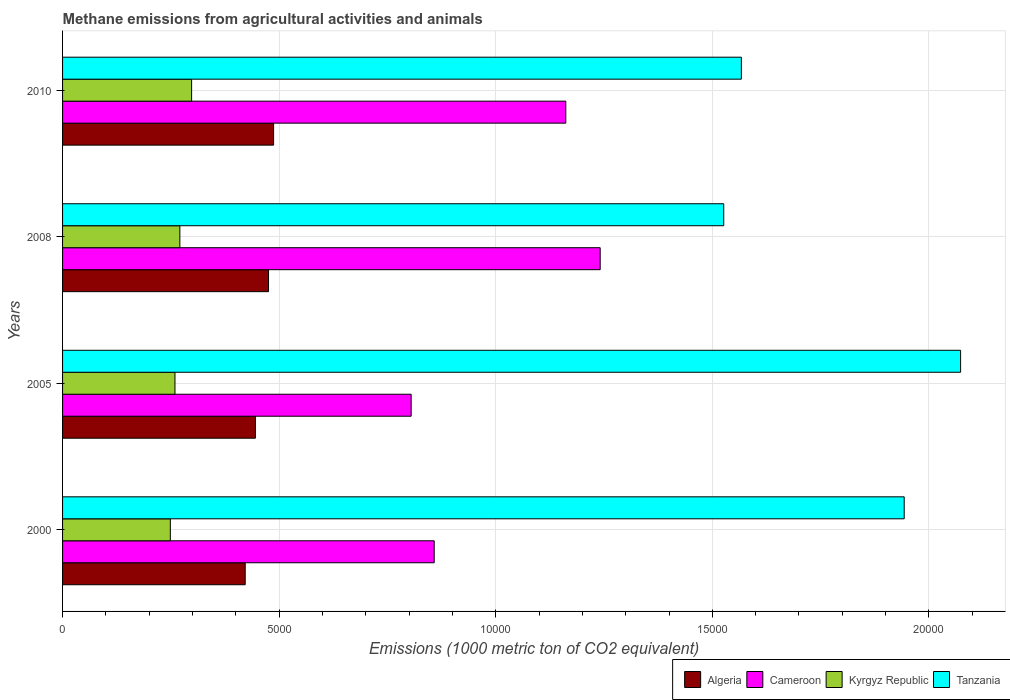Are the number of bars per tick equal to the number of legend labels?
Offer a terse response. Yes. Are the number of bars on each tick of the Y-axis equal?
Ensure brevity in your answer.  Yes. How many bars are there on the 2nd tick from the top?
Keep it short and to the point. 4. How many bars are there on the 2nd tick from the bottom?
Make the answer very short. 4. What is the label of the 2nd group of bars from the top?
Provide a succinct answer. 2008. In how many cases, is the number of bars for a given year not equal to the number of legend labels?
Keep it short and to the point. 0. What is the amount of methane emitted in Tanzania in 2000?
Make the answer very short. 1.94e+04. Across all years, what is the maximum amount of methane emitted in Algeria?
Your response must be concise. 4872.2. Across all years, what is the minimum amount of methane emitted in Tanzania?
Offer a very short reply. 1.53e+04. In which year was the amount of methane emitted in Kyrgyz Republic maximum?
Make the answer very short. 2010. In which year was the amount of methane emitted in Algeria minimum?
Make the answer very short. 2000. What is the total amount of methane emitted in Algeria in the graph?
Ensure brevity in your answer.  1.83e+04. What is the difference between the amount of methane emitted in Tanzania in 2000 and that in 2008?
Offer a terse response. 4166.4. What is the difference between the amount of methane emitted in Kyrgyz Republic in 2010 and the amount of methane emitted in Cameroon in 2008?
Your answer should be very brief. -9432.4. What is the average amount of methane emitted in Cameroon per year?
Your answer should be compact. 1.02e+04. In the year 2008, what is the difference between the amount of methane emitted in Cameroon and amount of methane emitted in Algeria?
Offer a very short reply. 7656.6. In how many years, is the amount of methane emitted in Algeria greater than 15000 1000 metric ton?
Offer a terse response. 0. What is the ratio of the amount of methane emitted in Tanzania in 2000 to that in 2010?
Provide a succinct answer. 1.24. What is the difference between the highest and the second highest amount of methane emitted in Cameroon?
Your answer should be compact. 793.8. What is the difference between the highest and the lowest amount of methane emitted in Tanzania?
Offer a very short reply. 5468. Is the sum of the amount of methane emitted in Tanzania in 2008 and 2010 greater than the maximum amount of methane emitted in Kyrgyz Republic across all years?
Make the answer very short. Yes. Is it the case that in every year, the sum of the amount of methane emitted in Algeria and amount of methane emitted in Tanzania is greater than the sum of amount of methane emitted in Cameroon and amount of methane emitted in Kyrgyz Republic?
Your response must be concise. Yes. What does the 4th bar from the top in 2010 represents?
Provide a succinct answer. Algeria. What does the 4th bar from the bottom in 2010 represents?
Provide a succinct answer. Tanzania. Is it the case that in every year, the sum of the amount of methane emitted in Algeria and amount of methane emitted in Cameroon is greater than the amount of methane emitted in Tanzania?
Make the answer very short. No. How many years are there in the graph?
Offer a very short reply. 4. Does the graph contain any zero values?
Offer a terse response. No. Does the graph contain grids?
Your response must be concise. Yes. How are the legend labels stacked?
Offer a very short reply. Horizontal. What is the title of the graph?
Offer a terse response. Methane emissions from agricultural activities and animals. Does "New Zealand" appear as one of the legend labels in the graph?
Provide a succinct answer. No. What is the label or title of the X-axis?
Your response must be concise. Emissions (1000 metric ton of CO2 equivalent). What is the label or title of the Y-axis?
Your answer should be compact. Years. What is the Emissions (1000 metric ton of CO2 equivalent) of Algeria in 2000?
Your answer should be compact. 4216.3. What is the Emissions (1000 metric ton of CO2 equivalent) of Cameroon in 2000?
Offer a very short reply. 8579.6. What is the Emissions (1000 metric ton of CO2 equivalent) of Kyrgyz Republic in 2000?
Provide a short and direct response. 2487.9. What is the Emissions (1000 metric ton of CO2 equivalent) of Tanzania in 2000?
Your answer should be very brief. 1.94e+04. What is the Emissions (1000 metric ton of CO2 equivalent) of Algeria in 2005?
Offer a very short reply. 4452.1. What is the Emissions (1000 metric ton of CO2 equivalent) in Cameroon in 2005?
Give a very brief answer. 8047.3. What is the Emissions (1000 metric ton of CO2 equivalent) in Kyrgyz Republic in 2005?
Ensure brevity in your answer.  2595. What is the Emissions (1000 metric ton of CO2 equivalent) in Tanzania in 2005?
Offer a terse response. 2.07e+04. What is the Emissions (1000 metric ton of CO2 equivalent) in Algeria in 2008?
Ensure brevity in your answer.  4754.7. What is the Emissions (1000 metric ton of CO2 equivalent) in Cameroon in 2008?
Provide a succinct answer. 1.24e+04. What is the Emissions (1000 metric ton of CO2 equivalent) in Kyrgyz Republic in 2008?
Keep it short and to the point. 2707.7. What is the Emissions (1000 metric ton of CO2 equivalent) of Tanzania in 2008?
Your answer should be compact. 1.53e+04. What is the Emissions (1000 metric ton of CO2 equivalent) of Algeria in 2010?
Keep it short and to the point. 4872.2. What is the Emissions (1000 metric ton of CO2 equivalent) in Cameroon in 2010?
Provide a succinct answer. 1.16e+04. What is the Emissions (1000 metric ton of CO2 equivalent) in Kyrgyz Republic in 2010?
Your response must be concise. 2978.9. What is the Emissions (1000 metric ton of CO2 equivalent) of Tanzania in 2010?
Keep it short and to the point. 1.57e+04. Across all years, what is the maximum Emissions (1000 metric ton of CO2 equivalent) in Algeria?
Keep it short and to the point. 4872.2. Across all years, what is the maximum Emissions (1000 metric ton of CO2 equivalent) of Cameroon?
Provide a short and direct response. 1.24e+04. Across all years, what is the maximum Emissions (1000 metric ton of CO2 equivalent) in Kyrgyz Republic?
Offer a very short reply. 2978.9. Across all years, what is the maximum Emissions (1000 metric ton of CO2 equivalent) in Tanzania?
Offer a very short reply. 2.07e+04. Across all years, what is the minimum Emissions (1000 metric ton of CO2 equivalent) in Algeria?
Make the answer very short. 4216.3. Across all years, what is the minimum Emissions (1000 metric ton of CO2 equivalent) in Cameroon?
Your answer should be compact. 8047.3. Across all years, what is the minimum Emissions (1000 metric ton of CO2 equivalent) in Kyrgyz Republic?
Your answer should be very brief. 2487.9. Across all years, what is the minimum Emissions (1000 metric ton of CO2 equivalent) of Tanzania?
Provide a succinct answer. 1.53e+04. What is the total Emissions (1000 metric ton of CO2 equivalent) in Algeria in the graph?
Provide a succinct answer. 1.83e+04. What is the total Emissions (1000 metric ton of CO2 equivalent) of Cameroon in the graph?
Offer a very short reply. 4.07e+04. What is the total Emissions (1000 metric ton of CO2 equivalent) in Kyrgyz Republic in the graph?
Give a very brief answer. 1.08e+04. What is the total Emissions (1000 metric ton of CO2 equivalent) in Tanzania in the graph?
Give a very brief answer. 7.11e+04. What is the difference between the Emissions (1000 metric ton of CO2 equivalent) in Algeria in 2000 and that in 2005?
Your answer should be very brief. -235.8. What is the difference between the Emissions (1000 metric ton of CO2 equivalent) of Cameroon in 2000 and that in 2005?
Provide a succinct answer. 532.3. What is the difference between the Emissions (1000 metric ton of CO2 equivalent) of Kyrgyz Republic in 2000 and that in 2005?
Offer a very short reply. -107.1. What is the difference between the Emissions (1000 metric ton of CO2 equivalent) of Tanzania in 2000 and that in 2005?
Your answer should be compact. -1301.6. What is the difference between the Emissions (1000 metric ton of CO2 equivalent) of Algeria in 2000 and that in 2008?
Keep it short and to the point. -538.4. What is the difference between the Emissions (1000 metric ton of CO2 equivalent) in Cameroon in 2000 and that in 2008?
Your answer should be very brief. -3831.7. What is the difference between the Emissions (1000 metric ton of CO2 equivalent) of Kyrgyz Republic in 2000 and that in 2008?
Make the answer very short. -219.8. What is the difference between the Emissions (1000 metric ton of CO2 equivalent) of Tanzania in 2000 and that in 2008?
Your answer should be compact. 4166.4. What is the difference between the Emissions (1000 metric ton of CO2 equivalent) in Algeria in 2000 and that in 2010?
Offer a terse response. -655.9. What is the difference between the Emissions (1000 metric ton of CO2 equivalent) of Cameroon in 2000 and that in 2010?
Give a very brief answer. -3037.9. What is the difference between the Emissions (1000 metric ton of CO2 equivalent) in Kyrgyz Republic in 2000 and that in 2010?
Offer a very short reply. -491. What is the difference between the Emissions (1000 metric ton of CO2 equivalent) in Tanzania in 2000 and that in 2010?
Ensure brevity in your answer.  3759.4. What is the difference between the Emissions (1000 metric ton of CO2 equivalent) of Algeria in 2005 and that in 2008?
Ensure brevity in your answer.  -302.6. What is the difference between the Emissions (1000 metric ton of CO2 equivalent) in Cameroon in 2005 and that in 2008?
Give a very brief answer. -4364. What is the difference between the Emissions (1000 metric ton of CO2 equivalent) in Kyrgyz Republic in 2005 and that in 2008?
Make the answer very short. -112.7. What is the difference between the Emissions (1000 metric ton of CO2 equivalent) of Tanzania in 2005 and that in 2008?
Offer a terse response. 5468. What is the difference between the Emissions (1000 metric ton of CO2 equivalent) in Algeria in 2005 and that in 2010?
Offer a terse response. -420.1. What is the difference between the Emissions (1000 metric ton of CO2 equivalent) of Cameroon in 2005 and that in 2010?
Ensure brevity in your answer.  -3570.2. What is the difference between the Emissions (1000 metric ton of CO2 equivalent) in Kyrgyz Republic in 2005 and that in 2010?
Offer a very short reply. -383.9. What is the difference between the Emissions (1000 metric ton of CO2 equivalent) of Tanzania in 2005 and that in 2010?
Provide a short and direct response. 5061. What is the difference between the Emissions (1000 metric ton of CO2 equivalent) in Algeria in 2008 and that in 2010?
Make the answer very short. -117.5. What is the difference between the Emissions (1000 metric ton of CO2 equivalent) in Cameroon in 2008 and that in 2010?
Ensure brevity in your answer.  793.8. What is the difference between the Emissions (1000 metric ton of CO2 equivalent) in Kyrgyz Republic in 2008 and that in 2010?
Offer a terse response. -271.2. What is the difference between the Emissions (1000 metric ton of CO2 equivalent) in Tanzania in 2008 and that in 2010?
Offer a terse response. -407. What is the difference between the Emissions (1000 metric ton of CO2 equivalent) of Algeria in 2000 and the Emissions (1000 metric ton of CO2 equivalent) of Cameroon in 2005?
Ensure brevity in your answer.  -3831. What is the difference between the Emissions (1000 metric ton of CO2 equivalent) in Algeria in 2000 and the Emissions (1000 metric ton of CO2 equivalent) in Kyrgyz Republic in 2005?
Provide a succinct answer. 1621.3. What is the difference between the Emissions (1000 metric ton of CO2 equivalent) of Algeria in 2000 and the Emissions (1000 metric ton of CO2 equivalent) of Tanzania in 2005?
Provide a succinct answer. -1.65e+04. What is the difference between the Emissions (1000 metric ton of CO2 equivalent) in Cameroon in 2000 and the Emissions (1000 metric ton of CO2 equivalent) in Kyrgyz Republic in 2005?
Provide a short and direct response. 5984.6. What is the difference between the Emissions (1000 metric ton of CO2 equivalent) of Cameroon in 2000 and the Emissions (1000 metric ton of CO2 equivalent) of Tanzania in 2005?
Ensure brevity in your answer.  -1.22e+04. What is the difference between the Emissions (1000 metric ton of CO2 equivalent) of Kyrgyz Republic in 2000 and the Emissions (1000 metric ton of CO2 equivalent) of Tanzania in 2005?
Ensure brevity in your answer.  -1.82e+04. What is the difference between the Emissions (1000 metric ton of CO2 equivalent) in Algeria in 2000 and the Emissions (1000 metric ton of CO2 equivalent) in Cameroon in 2008?
Keep it short and to the point. -8195. What is the difference between the Emissions (1000 metric ton of CO2 equivalent) in Algeria in 2000 and the Emissions (1000 metric ton of CO2 equivalent) in Kyrgyz Republic in 2008?
Offer a terse response. 1508.6. What is the difference between the Emissions (1000 metric ton of CO2 equivalent) in Algeria in 2000 and the Emissions (1000 metric ton of CO2 equivalent) in Tanzania in 2008?
Give a very brief answer. -1.10e+04. What is the difference between the Emissions (1000 metric ton of CO2 equivalent) of Cameroon in 2000 and the Emissions (1000 metric ton of CO2 equivalent) of Kyrgyz Republic in 2008?
Make the answer very short. 5871.9. What is the difference between the Emissions (1000 metric ton of CO2 equivalent) in Cameroon in 2000 and the Emissions (1000 metric ton of CO2 equivalent) in Tanzania in 2008?
Provide a succinct answer. -6683.9. What is the difference between the Emissions (1000 metric ton of CO2 equivalent) in Kyrgyz Republic in 2000 and the Emissions (1000 metric ton of CO2 equivalent) in Tanzania in 2008?
Provide a succinct answer. -1.28e+04. What is the difference between the Emissions (1000 metric ton of CO2 equivalent) in Algeria in 2000 and the Emissions (1000 metric ton of CO2 equivalent) in Cameroon in 2010?
Make the answer very short. -7401.2. What is the difference between the Emissions (1000 metric ton of CO2 equivalent) in Algeria in 2000 and the Emissions (1000 metric ton of CO2 equivalent) in Kyrgyz Republic in 2010?
Your answer should be very brief. 1237.4. What is the difference between the Emissions (1000 metric ton of CO2 equivalent) of Algeria in 2000 and the Emissions (1000 metric ton of CO2 equivalent) of Tanzania in 2010?
Offer a very short reply. -1.15e+04. What is the difference between the Emissions (1000 metric ton of CO2 equivalent) in Cameroon in 2000 and the Emissions (1000 metric ton of CO2 equivalent) in Kyrgyz Republic in 2010?
Provide a short and direct response. 5600.7. What is the difference between the Emissions (1000 metric ton of CO2 equivalent) in Cameroon in 2000 and the Emissions (1000 metric ton of CO2 equivalent) in Tanzania in 2010?
Offer a terse response. -7090.9. What is the difference between the Emissions (1000 metric ton of CO2 equivalent) of Kyrgyz Republic in 2000 and the Emissions (1000 metric ton of CO2 equivalent) of Tanzania in 2010?
Offer a terse response. -1.32e+04. What is the difference between the Emissions (1000 metric ton of CO2 equivalent) in Algeria in 2005 and the Emissions (1000 metric ton of CO2 equivalent) in Cameroon in 2008?
Keep it short and to the point. -7959.2. What is the difference between the Emissions (1000 metric ton of CO2 equivalent) in Algeria in 2005 and the Emissions (1000 metric ton of CO2 equivalent) in Kyrgyz Republic in 2008?
Offer a very short reply. 1744.4. What is the difference between the Emissions (1000 metric ton of CO2 equivalent) of Algeria in 2005 and the Emissions (1000 metric ton of CO2 equivalent) of Tanzania in 2008?
Your response must be concise. -1.08e+04. What is the difference between the Emissions (1000 metric ton of CO2 equivalent) in Cameroon in 2005 and the Emissions (1000 metric ton of CO2 equivalent) in Kyrgyz Republic in 2008?
Ensure brevity in your answer.  5339.6. What is the difference between the Emissions (1000 metric ton of CO2 equivalent) in Cameroon in 2005 and the Emissions (1000 metric ton of CO2 equivalent) in Tanzania in 2008?
Your answer should be very brief. -7216.2. What is the difference between the Emissions (1000 metric ton of CO2 equivalent) of Kyrgyz Republic in 2005 and the Emissions (1000 metric ton of CO2 equivalent) of Tanzania in 2008?
Make the answer very short. -1.27e+04. What is the difference between the Emissions (1000 metric ton of CO2 equivalent) of Algeria in 2005 and the Emissions (1000 metric ton of CO2 equivalent) of Cameroon in 2010?
Your answer should be very brief. -7165.4. What is the difference between the Emissions (1000 metric ton of CO2 equivalent) in Algeria in 2005 and the Emissions (1000 metric ton of CO2 equivalent) in Kyrgyz Republic in 2010?
Keep it short and to the point. 1473.2. What is the difference between the Emissions (1000 metric ton of CO2 equivalent) of Algeria in 2005 and the Emissions (1000 metric ton of CO2 equivalent) of Tanzania in 2010?
Give a very brief answer. -1.12e+04. What is the difference between the Emissions (1000 metric ton of CO2 equivalent) of Cameroon in 2005 and the Emissions (1000 metric ton of CO2 equivalent) of Kyrgyz Republic in 2010?
Your answer should be compact. 5068.4. What is the difference between the Emissions (1000 metric ton of CO2 equivalent) of Cameroon in 2005 and the Emissions (1000 metric ton of CO2 equivalent) of Tanzania in 2010?
Make the answer very short. -7623.2. What is the difference between the Emissions (1000 metric ton of CO2 equivalent) in Kyrgyz Republic in 2005 and the Emissions (1000 metric ton of CO2 equivalent) in Tanzania in 2010?
Your response must be concise. -1.31e+04. What is the difference between the Emissions (1000 metric ton of CO2 equivalent) in Algeria in 2008 and the Emissions (1000 metric ton of CO2 equivalent) in Cameroon in 2010?
Ensure brevity in your answer.  -6862.8. What is the difference between the Emissions (1000 metric ton of CO2 equivalent) in Algeria in 2008 and the Emissions (1000 metric ton of CO2 equivalent) in Kyrgyz Republic in 2010?
Keep it short and to the point. 1775.8. What is the difference between the Emissions (1000 metric ton of CO2 equivalent) of Algeria in 2008 and the Emissions (1000 metric ton of CO2 equivalent) of Tanzania in 2010?
Your answer should be compact. -1.09e+04. What is the difference between the Emissions (1000 metric ton of CO2 equivalent) in Cameroon in 2008 and the Emissions (1000 metric ton of CO2 equivalent) in Kyrgyz Republic in 2010?
Your response must be concise. 9432.4. What is the difference between the Emissions (1000 metric ton of CO2 equivalent) of Cameroon in 2008 and the Emissions (1000 metric ton of CO2 equivalent) of Tanzania in 2010?
Your answer should be compact. -3259.2. What is the difference between the Emissions (1000 metric ton of CO2 equivalent) in Kyrgyz Republic in 2008 and the Emissions (1000 metric ton of CO2 equivalent) in Tanzania in 2010?
Offer a very short reply. -1.30e+04. What is the average Emissions (1000 metric ton of CO2 equivalent) in Algeria per year?
Keep it short and to the point. 4573.82. What is the average Emissions (1000 metric ton of CO2 equivalent) of Cameroon per year?
Keep it short and to the point. 1.02e+04. What is the average Emissions (1000 metric ton of CO2 equivalent) in Kyrgyz Republic per year?
Provide a succinct answer. 2692.38. What is the average Emissions (1000 metric ton of CO2 equivalent) of Tanzania per year?
Give a very brief answer. 1.78e+04. In the year 2000, what is the difference between the Emissions (1000 metric ton of CO2 equivalent) of Algeria and Emissions (1000 metric ton of CO2 equivalent) of Cameroon?
Offer a very short reply. -4363.3. In the year 2000, what is the difference between the Emissions (1000 metric ton of CO2 equivalent) of Algeria and Emissions (1000 metric ton of CO2 equivalent) of Kyrgyz Republic?
Offer a terse response. 1728.4. In the year 2000, what is the difference between the Emissions (1000 metric ton of CO2 equivalent) in Algeria and Emissions (1000 metric ton of CO2 equivalent) in Tanzania?
Give a very brief answer. -1.52e+04. In the year 2000, what is the difference between the Emissions (1000 metric ton of CO2 equivalent) of Cameroon and Emissions (1000 metric ton of CO2 equivalent) of Kyrgyz Republic?
Keep it short and to the point. 6091.7. In the year 2000, what is the difference between the Emissions (1000 metric ton of CO2 equivalent) in Cameroon and Emissions (1000 metric ton of CO2 equivalent) in Tanzania?
Offer a very short reply. -1.09e+04. In the year 2000, what is the difference between the Emissions (1000 metric ton of CO2 equivalent) in Kyrgyz Republic and Emissions (1000 metric ton of CO2 equivalent) in Tanzania?
Ensure brevity in your answer.  -1.69e+04. In the year 2005, what is the difference between the Emissions (1000 metric ton of CO2 equivalent) of Algeria and Emissions (1000 metric ton of CO2 equivalent) of Cameroon?
Keep it short and to the point. -3595.2. In the year 2005, what is the difference between the Emissions (1000 metric ton of CO2 equivalent) of Algeria and Emissions (1000 metric ton of CO2 equivalent) of Kyrgyz Republic?
Provide a succinct answer. 1857.1. In the year 2005, what is the difference between the Emissions (1000 metric ton of CO2 equivalent) of Algeria and Emissions (1000 metric ton of CO2 equivalent) of Tanzania?
Provide a short and direct response. -1.63e+04. In the year 2005, what is the difference between the Emissions (1000 metric ton of CO2 equivalent) in Cameroon and Emissions (1000 metric ton of CO2 equivalent) in Kyrgyz Republic?
Keep it short and to the point. 5452.3. In the year 2005, what is the difference between the Emissions (1000 metric ton of CO2 equivalent) of Cameroon and Emissions (1000 metric ton of CO2 equivalent) of Tanzania?
Provide a succinct answer. -1.27e+04. In the year 2005, what is the difference between the Emissions (1000 metric ton of CO2 equivalent) in Kyrgyz Republic and Emissions (1000 metric ton of CO2 equivalent) in Tanzania?
Your answer should be very brief. -1.81e+04. In the year 2008, what is the difference between the Emissions (1000 metric ton of CO2 equivalent) in Algeria and Emissions (1000 metric ton of CO2 equivalent) in Cameroon?
Ensure brevity in your answer.  -7656.6. In the year 2008, what is the difference between the Emissions (1000 metric ton of CO2 equivalent) in Algeria and Emissions (1000 metric ton of CO2 equivalent) in Kyrgyz Republic?
Keep it short and to the point. 2047. In the year 2008, what is the difference between the Emissions (1000 metric ton of CO2 equivalent) of Algeria and Emissions (1000 metric ton of CO2 equivalent) of Tanzania?
Your answer should be compact. -1.05e+04. In the year 2008, what is the difference between the Emissions (1000 metric ton of CO2 equivalent) in Cameroon and Emissions (1000 metric ton of CO2 equivalent) in Kyrgyz Republic?
Ensure brevity in your answer.  9703.6. In the year 2008, what is the difference between the Emissions (1000 metric ton of CO2 equivalent) in Cameroon and Emissions (1000 metric ton of CO2 equivalent) in Tanzania?
Provide a short and direct response. -2852.2. In the year 2008, what is the difference between the Emissions (1000 metric ton of CO2 equivalent) of Kyrgyz Republic and Emissions (1000 metric ton of CO2 equivalent) of Tanzania?
Your answer should be compact. -1.26e+04. In the year 2010, what is the difference between the Emissions (1000 metric ton of CO2 equivalent) of Algeria and Emissions (1000 metric ton of CO2 equivalent) of Cameroon?
Give a very brief answer. -6745.3. In the year 2010, what is the difference between the Emissions (1000 metric ton of CO2 equivalent) of Algeria and Emissions (1000 metric ton of CO2 equivalent) of Kyrgyz Republic?
Provide a short and direct response. 1893.3. In the year 2010, what is the difference between the Emissions (1000 metric ton of CO2 equivalent) in Algeria and Emissions (1000 metric ton of CO2 equivalent) in Tanzania?
Provide a short and direct response. -1.08e+04. In the year 2010, what is the difference between the Emissions (1000 metric ton of CO2 equivalent) of Cameroon and Emissions (1000 metric ton of CO2 equivalent) of Kyrgyz Republic?
Provide a succinct answer. 8638.6. In the year 2010, what is the difference between the Emissions (1000 metric ton of CO2 equivalent) in Cameroon and Emissions (1000 metric ton of CO2 equivalent) in Tanzania?
Provide a short and direct response. -4053. In the year 2010, what is the difference between the Emissions (1000 metric ton of CO2 equivalent) in Kyrgyz Republic and Emissions (1000 metric ton of CO2 equivalent) in Tanzania?
Make the answer very short. -1.27e+04. What is the ratio of the Emissions (1000 metric ton of CO2 equivalent) of Algeria in 2000 to that in 2005?
Ensure brevity in your answer.  0.95. What is the ratio of the Emissions (1000 metric ton of CO2 equivalent) of Cameroon in 2000 to that in 2005?
Provide a succinct answer. 1.07. What is the ratio of the Emissions (1000 metric ton of CO2 equivalent) in Kyrgyz Republic in 2000 to that in 2005?
Your answer should be compact. 0.96. What is the ratio of the Emissions (1000 metric ton of CO2 equivalent) of Tanzania in 2000 to that in 2005?
Offer a terse response. 0.94. What is the ratio of the Emissions (1000 metric ton of CO2 equivalent) in Algeria in 2000 to that in 2008?
Your answer should be very brief. 0.89. What is the ratio of the Emissions (1000 metric ton of CO2 equivalent) in Cameroon in 2000 to that in 2008?
Give a very brief answer. 0.69. What is the ratio of the Emissions (1000 metric ton of CO2 equivalent) in Kyrgyz Republic in 2000 to that in 2008?
Provide a short and direct response. 0.92. What is the ratio of the Emissions (1000 metric ton of CO2 equivalent) in Tanzania in 2000 to that in 2008?
Give a very brief answer. 1.27. What is the ratio of the Emissions (1000 metric ton of CO2 equivalent) of Algeria in 2000 to that in 2010?
Ensure brevity in your answer.  0.87. What is the ratio of the Emissions (1000 metric ton of CO2 equivalent) in Cameroon in 2000 to that in 2010?
Keep it short and to the point. 0.74. What is the ratio of the Emissions (1000 metric ton of CO2 equivalent) in Kyrgyz Republic in 2000 to that in 2010?
Make the answer very short. 0.84. What is the ratio of the Emissions (1000 metric ton of CO2 equivalent) in Tanzania in 2000 to that in 2010?
Make the answer very short. 1.24. What is the ratio of the Emissions (1000 metric ton of CO2 equivalent) of Algeria in 2005 to that in 2008?
Your answer should be compact. 0.94. What is the ratio of the Emissions (1000 metric ton of CO2 equivalent) in Cameroon in 2005 to that in 2008?
Provide a succinct answer. 0.65. What is the ratio of the Emissions (1000 metric ton of CO2 equivalent) of Kyrgyz Republic in 2005 to that in 2008?
Your answer should be very brief. 0.96. What is the ratio of the Emissions (1000 metric ton of CO2 equivalent) in Tanzania in 2005 to that in 2008?
Provide a short and direct response. 1.36. What is the ratio of the Emissions (1000 metric ton of CO2 equivalent) in Algeria in 2005 to that in 2010?
Offer a terse response. 0.91. What is the ratio of the Emissions (1000 metric ton of CO2 equivalent) in Cameroon in 2005 to that in 2010?
Your response must be concise. 0.69. What is the ratio of the Emissions (1000 metric ton of CO2 equivalent) in Kyrgyz Republic in 2005 to that in 2010?
Offer a very short reply. 0.87. What is the ratio of the Emissions (1000 metric ton of CO2 equivalent) in Tanzania in 2005 to that in 2010?
Your answer should be compact. 1.32. What is the ratio of the Emissions (1000 metric ton of CO2 equivalent) in Algeria in 2008 to that in 2010?
Make the answer very short. 0.98. What is the ratio of the Emissions (1000 metric ton of CO2 equivalent) in Cameroon in 2008 to that in 2010?
Your answer should be compact. 1.07. What is the ratio of the Emissions (1000 metric ton of CO2 equivalent) of Kyrgyz Republic in 2008 to that in 2010?
Make the answer very short. 0.91. What is the difference between the highest and the second highest Emissions (1000 metric ton of CO2 equivalent) in Algeria?
Your answer should be very brief. 117.5. What is the difference between the highest and the second highest Emissions (1000 metric ton of CO2 equivalent) in Cameroon?
Your answer should be very brief. 793.8. What is the difference between the highest and the second highest Emissions (1000 metric ton of CO2 equivalent) of Kyrgyz Republic?
Make the answer very short. 271.2. What is the difference between the highest and the second highest Emissions (1000 metric ton of CO2 equivalent) in Tanzania?
Your response must be concise. 1301.6. What is the difference between the highest and the lowest Emissions (1000 metric ton of CO2 equivalent) of Algeria?
Your answer should be compact. 655.9. What is the difference between the highest and the lowest Emissions (1000 metric ton of CO2 equivalent) of Cameroon?
Your answer should be compact. 4364. What is the difference between the highest and the lowest Emissions (1000 metric ton of CO2 equivalent) of Kyrgyz Republic?
Provide a succinct answer. 491. What is the difference between the highest and the lowest Emissions (1000 metric ton of CO2 equivalent) of Tanzania?
Keep it short and to the point. 5468. 